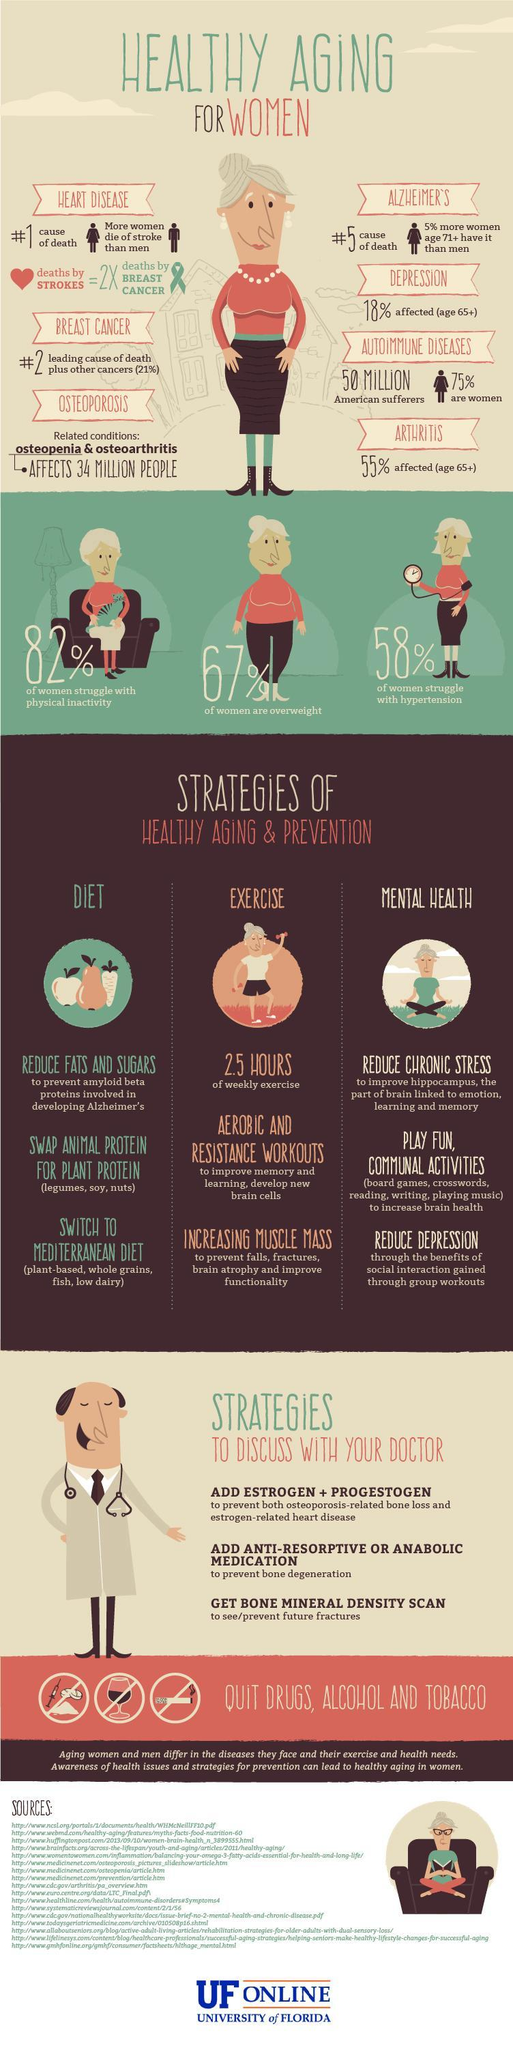Which activity helps to improve memory and develop new brain cells?
Answer the question with a short phrase. aerobic and resistance workouts What can be replaced by legumes, soy and nuts in diet? Animal protein How many of the women are overweight? 67% Which condition is seen in 5% more women over 71 than men? Alzheimer's What percent of women struggle with physical inactivity? 82% What condition affects 55% of women above the age of 65? arthritis What is the recommended duration of exercise per week? 2.5 hours What percent of women have struggle with high blood pressure? 58% What will help to prevent falls, fractures, brain atrophy and improve functionality? Increasing muscle mass How does increased social interaction through group activities help? Reduce depression 